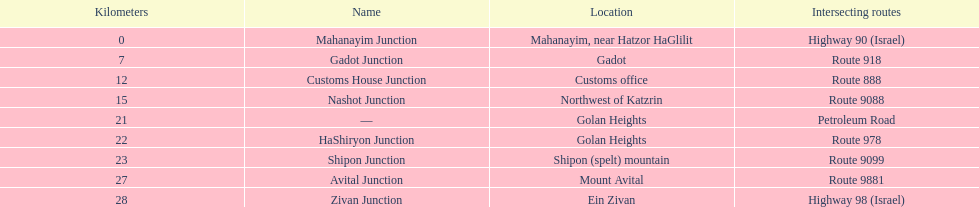What is the count of paths that cross highway 91? 9. 